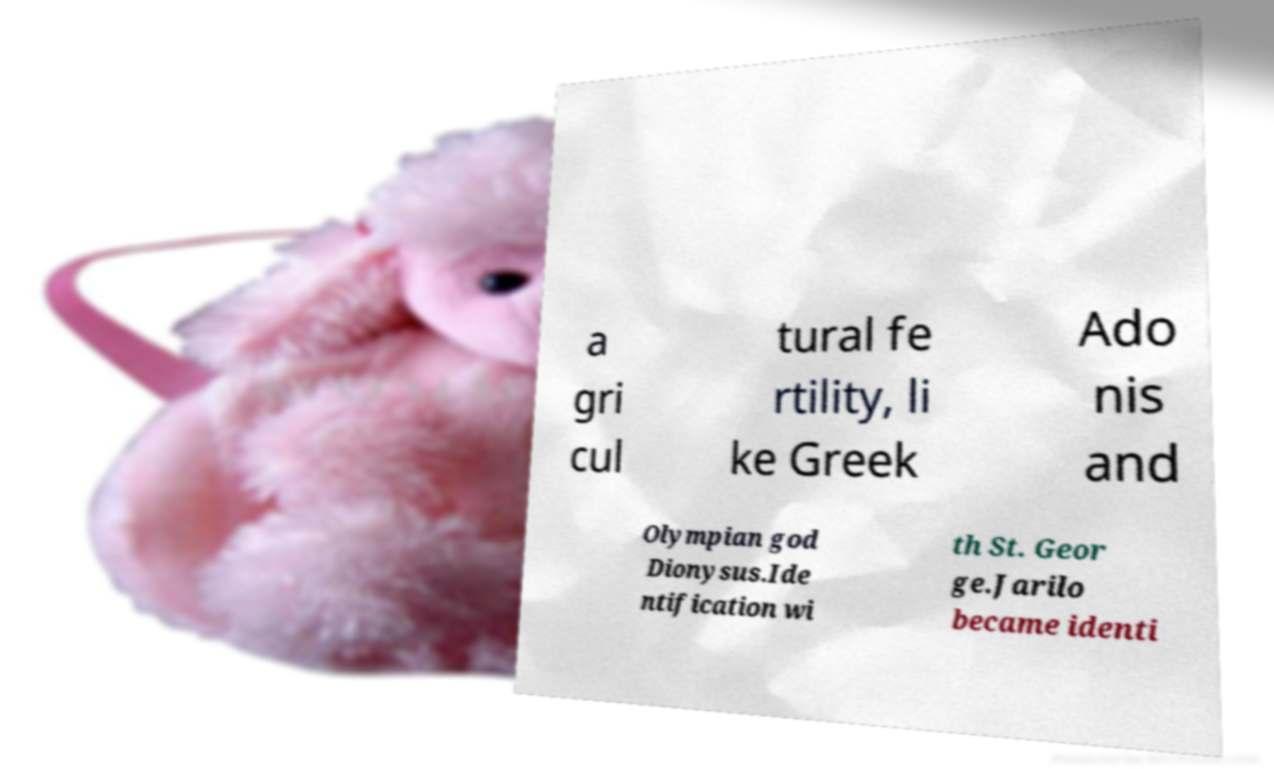Could you assist in decoding the text presented in this image and type it out clearly? a gri cul tural fe rtility, li ke Greek Ado nis and Olympian god Dionysus.Ide ntification wi th St. Geor ge.Jarilo became identi 